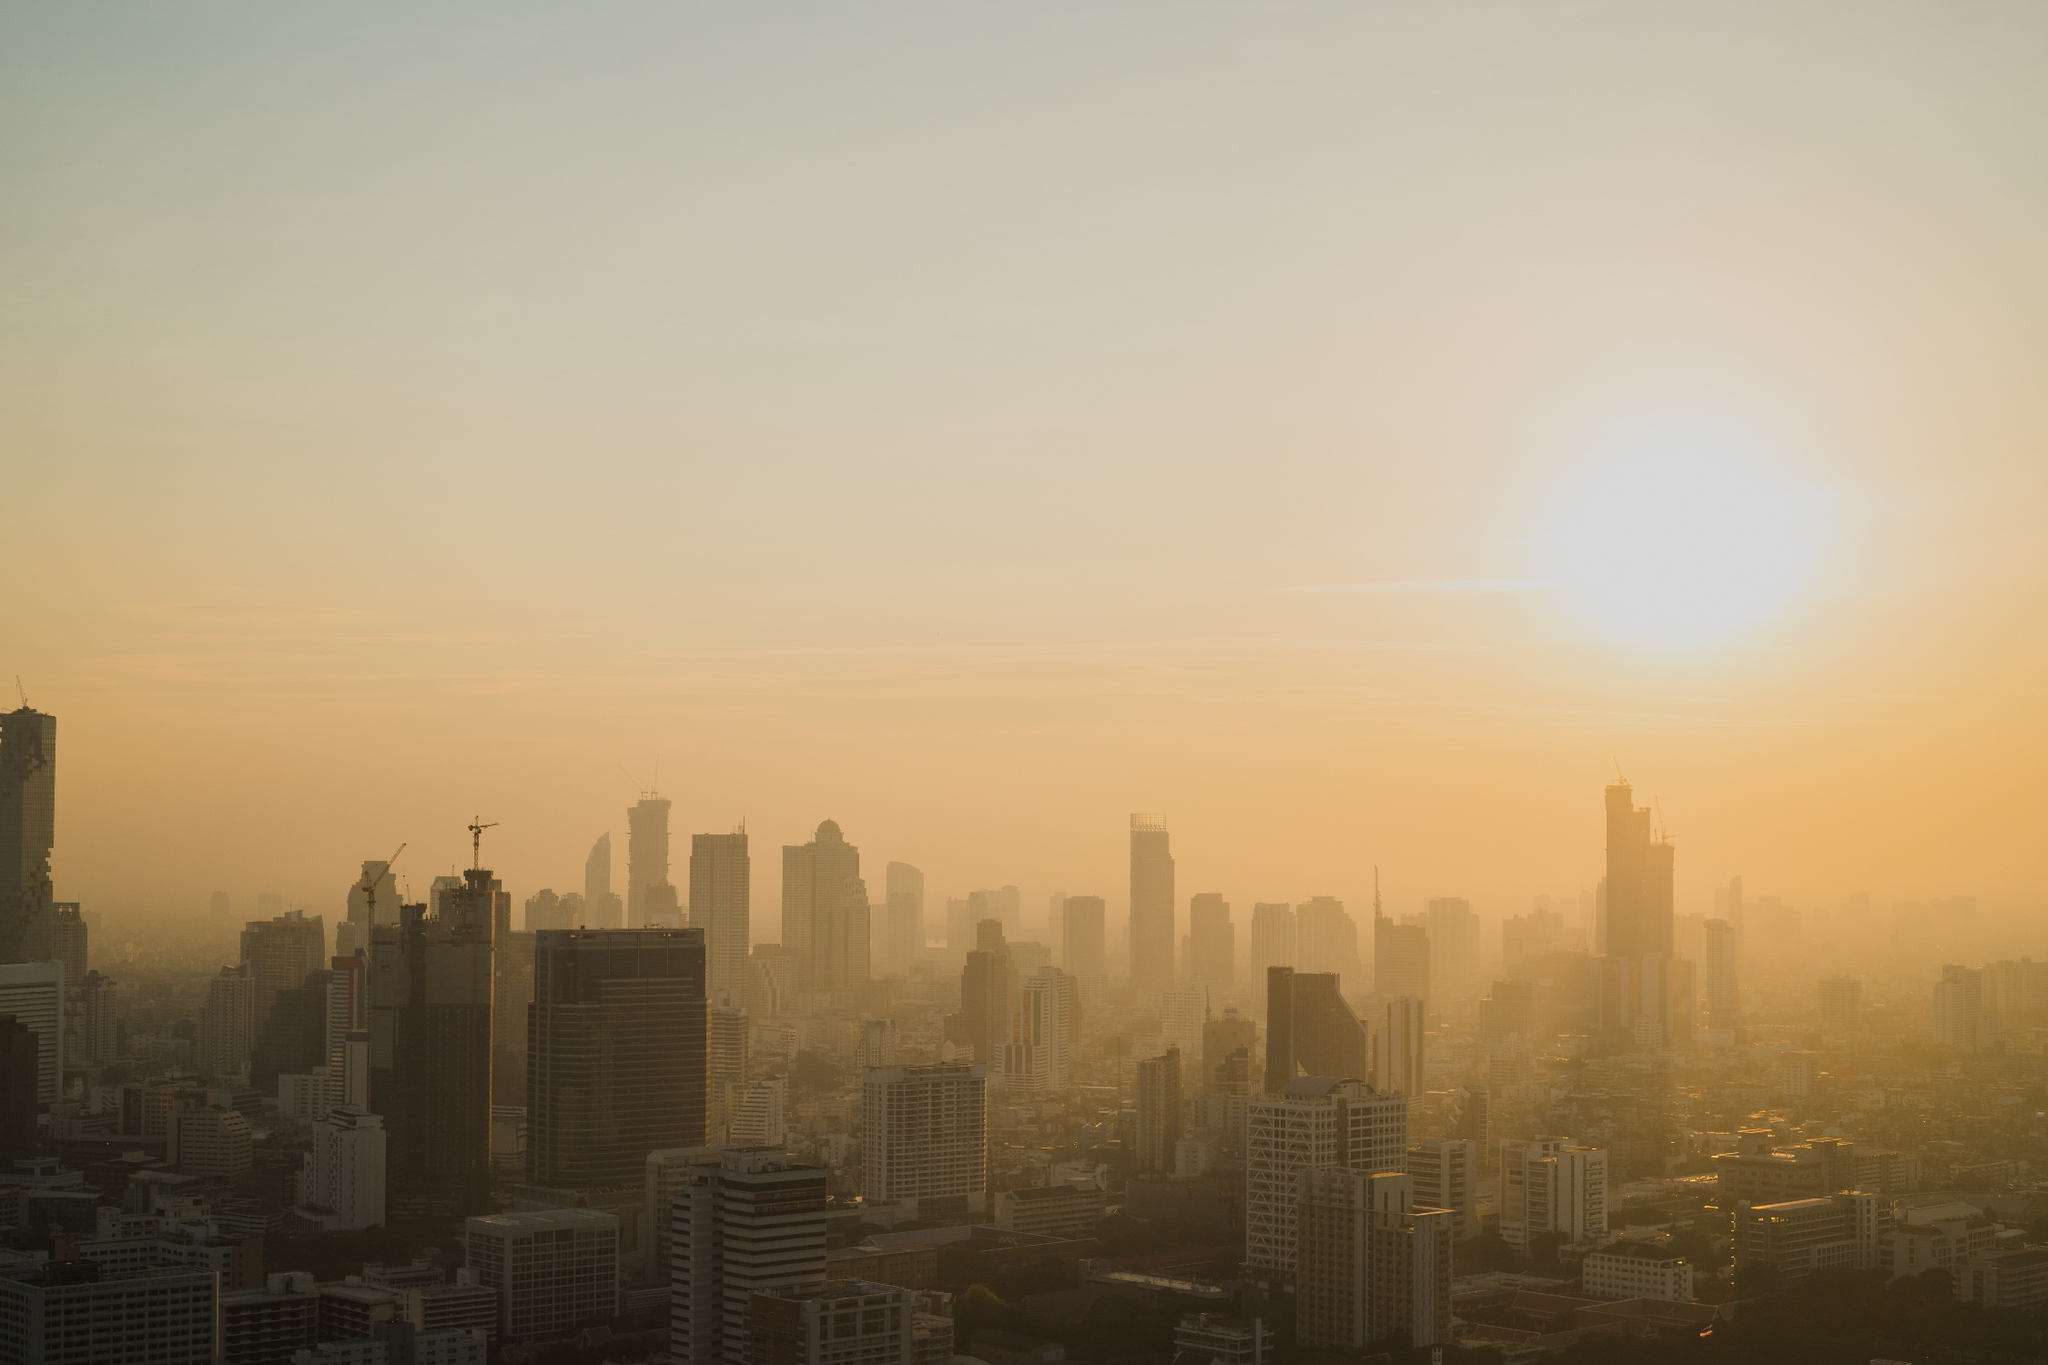Analyze the image in a comprehensive and detailed manner. The image captures the stunning skyline of Bangkok, Thailand at the break of dawn. The city is viewed from a high vantage point, offering a panoramic view of the urban landscape. The sun is just beginning to rise on the right side of the frame, casting a warm, golden light that illuminates the cityscape. The buildings, a mix of modern skyscrapers and older, shorter structures, are bathed in this glow, creating a contrast of light and shadow. The sky above is painted in shades of hazy orange, adding to the ethereal quality of the scene. However, a layer of smog hangs over the city, a stark reminder of the environmental challenges faced by many urban areas today. Despite this, the image encapsulates the beauty and complexity of Bangkok, a city where tradition and modernity coexist. 